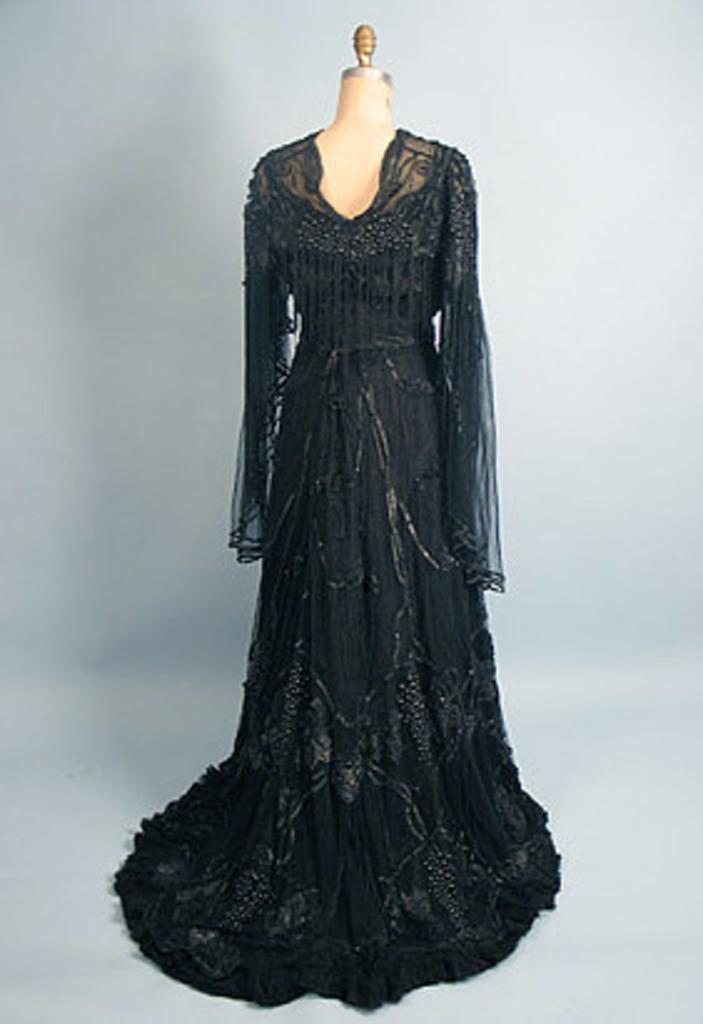How would you summarize this image in a sentence or two? In this picture there is a cloth on the mannequin which is black in colour. 